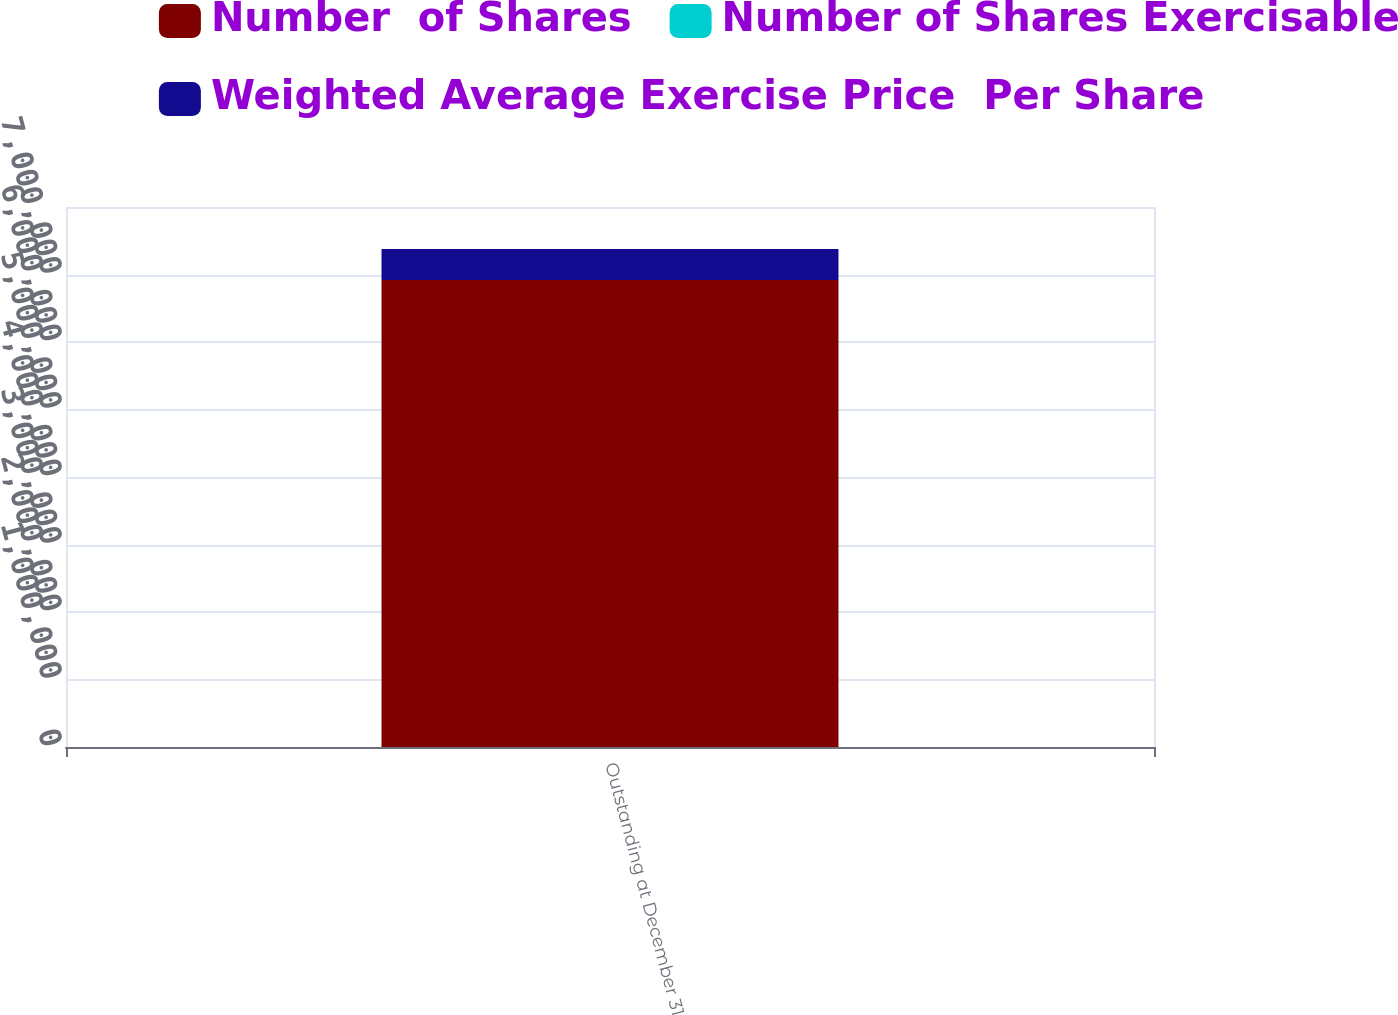Convert chart. <chart><loc_0><loc_0><loc_500><loc_500><stacked_bar_chart><ecel><fcel>Outstanding at December 31<nl><fcel>Number  of Shares<fcel>6.92008e+06<nl><fcel>Number of Shares Exercisable<fcel>14.31<nl><fcel>Weighted Average Exercise Price  Per Share<fcel>459262<nl></chart> 